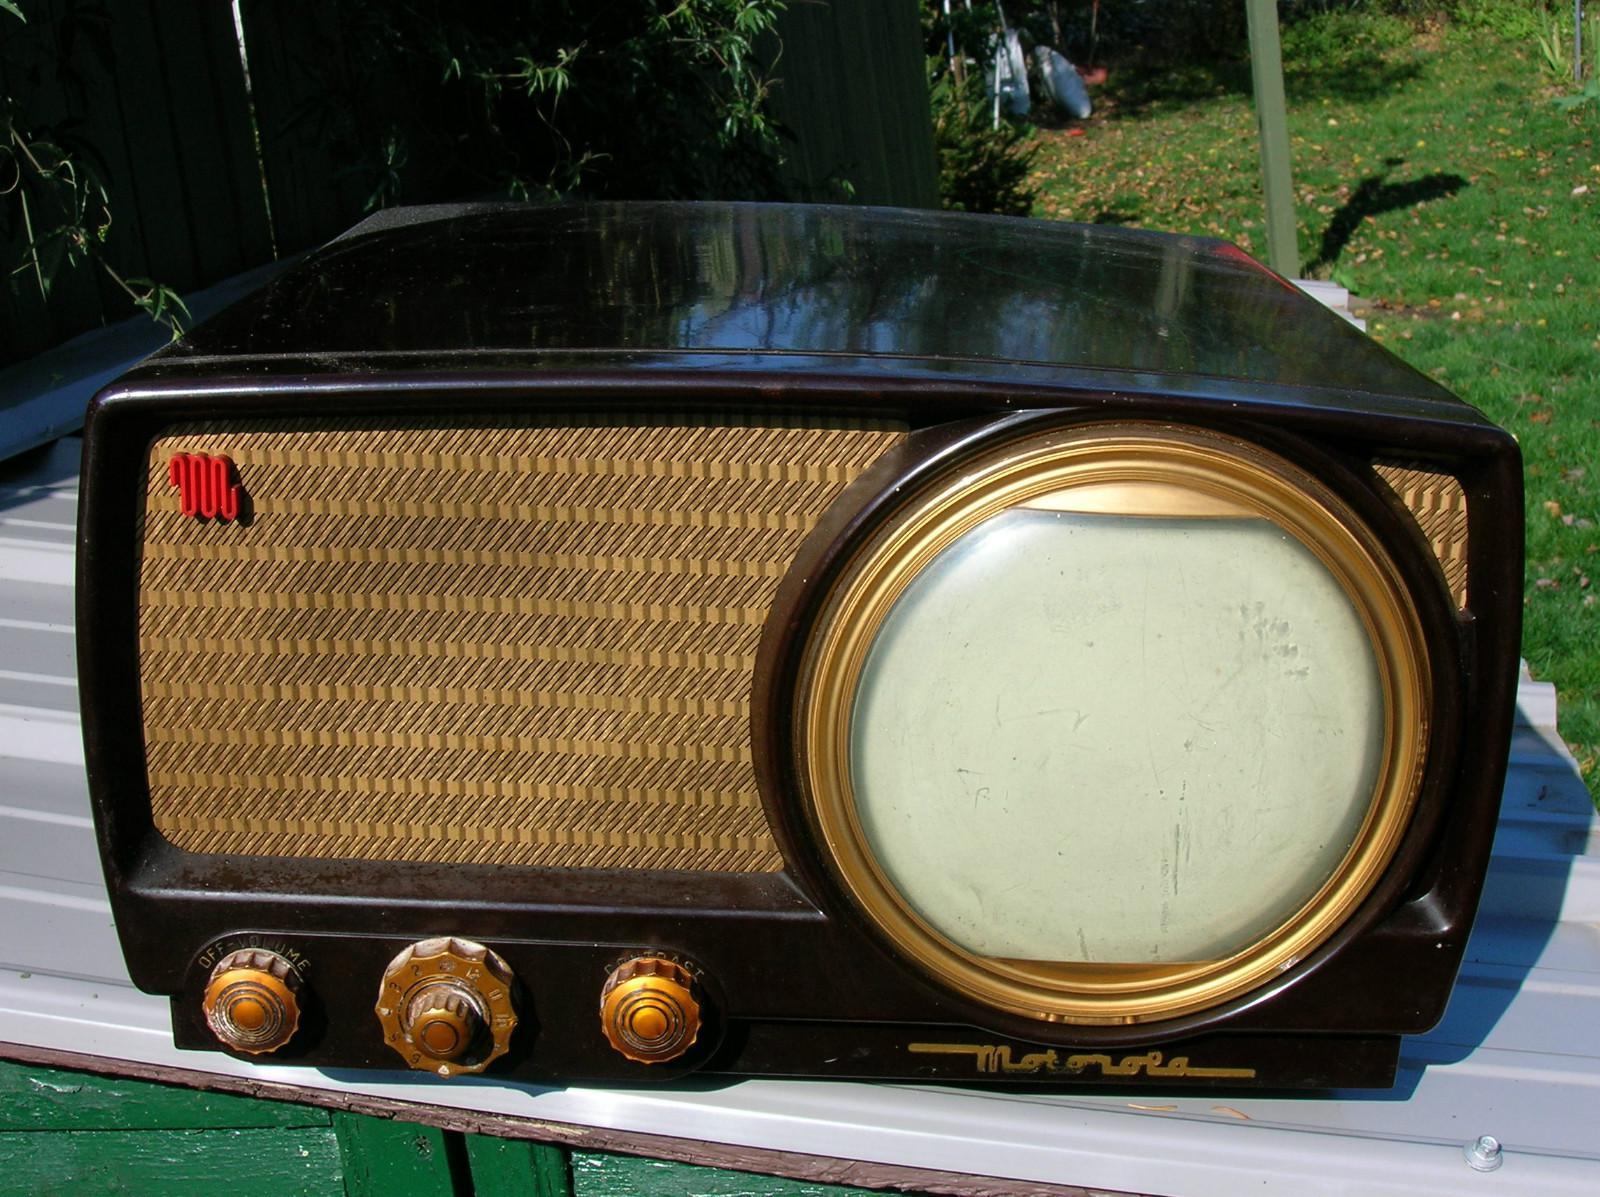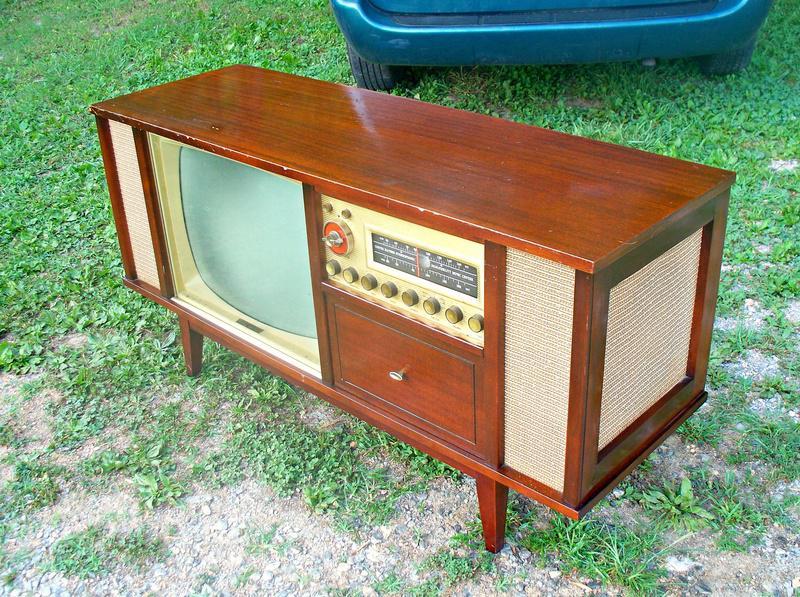The first image is the image on the left, the second image is the image on the right. Analyze the images presented: Is the assertion "Exactly one TV has four legs sitting on a hard, non-grassy surface, and at least one TV has a screen with four rounded corners." valid? Answer yes or no. No. The first image is the image on the left, the second image is the image on the right. For the images shown, is this caption "In one image, a television and a radio unit are housed in a long wooden console cabinet on short legs that has speakers on the front and end." true? Answer yes or no. Yes. 